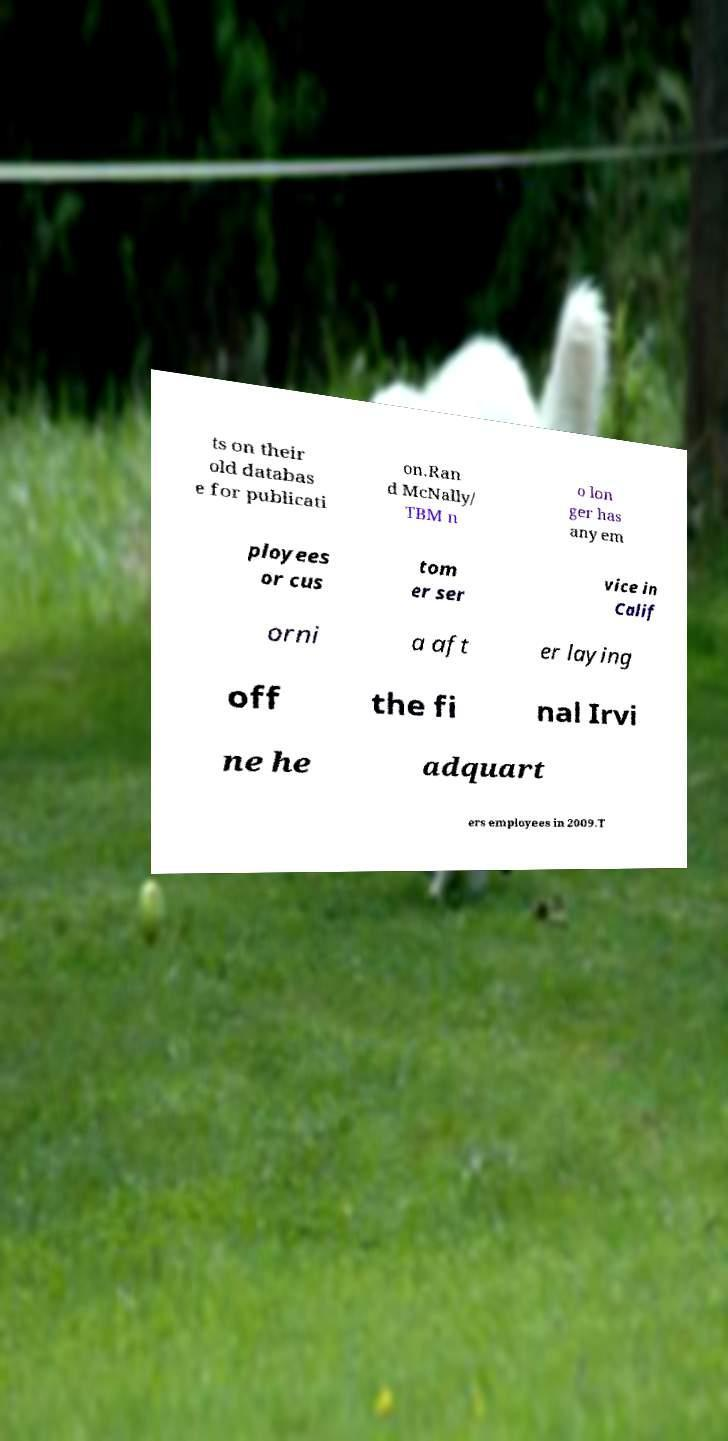Please identify and transcribe the text found in this image. ts on their old databas e for publicati on.Ran d McNally/ TBM n o lon ger has any em ployees or cus tom er ser vice in Calif orni a aft er laying off the fi nal Irvi ne he adquart ers employees in 2009.T 